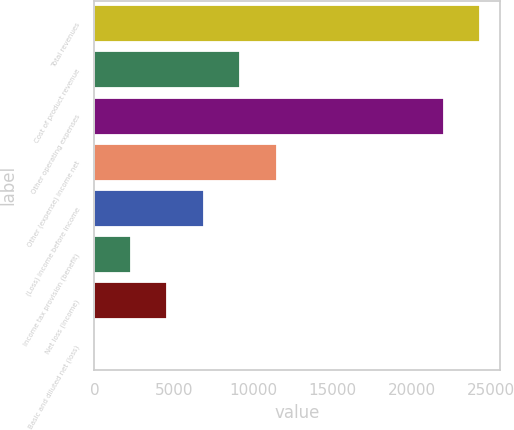<chart> <loc_0><loc_0><loc_500><loc_500><bar_chart><fcel>Total revenues<fcel>Cost of product revenue<fcel>Other operating expenses<fcel>Other (expense) income net<fcel>(Loss) income before income<fcel>Income tax provision (benefit)<fcel>Net loss (income)<fcel>Basic and diluted net (loss)<nl><fcel>24311.9<fcel>9191.63<fcel>22014<fcel>11489.5<fcel>6893.73<fcel>2297.93<fcel>4595.83<fcel>0.03<nl></chart> 